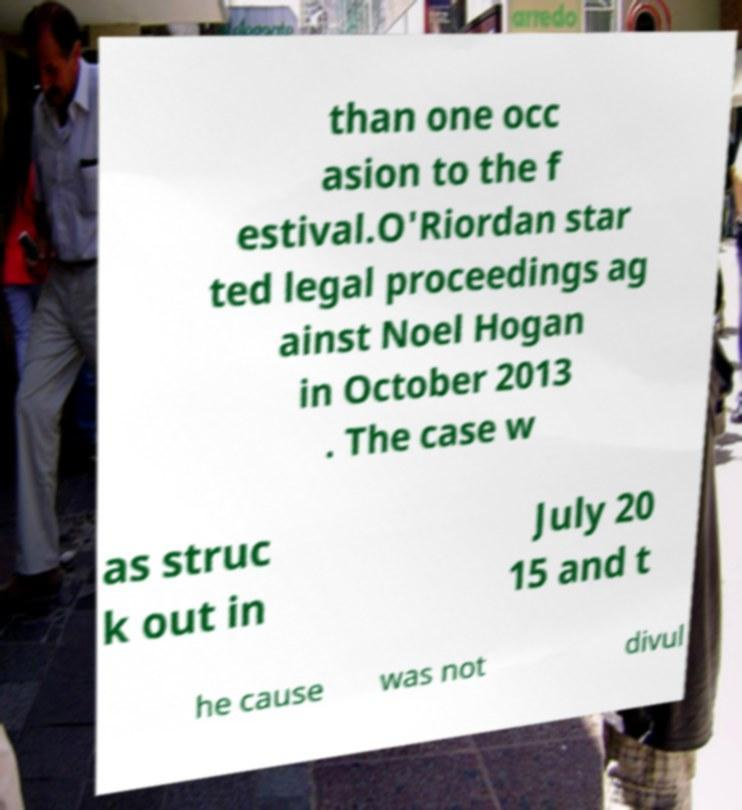There's text embedded in this image that I need extracted. Can you transcribe it verbatim? than one occ asion to the f estival.O'Riordan star ted legal proceedings ag ainst Noel Hogan in October 2013 . The case w as struc k out in July 20 15 and t he cause was not divul 